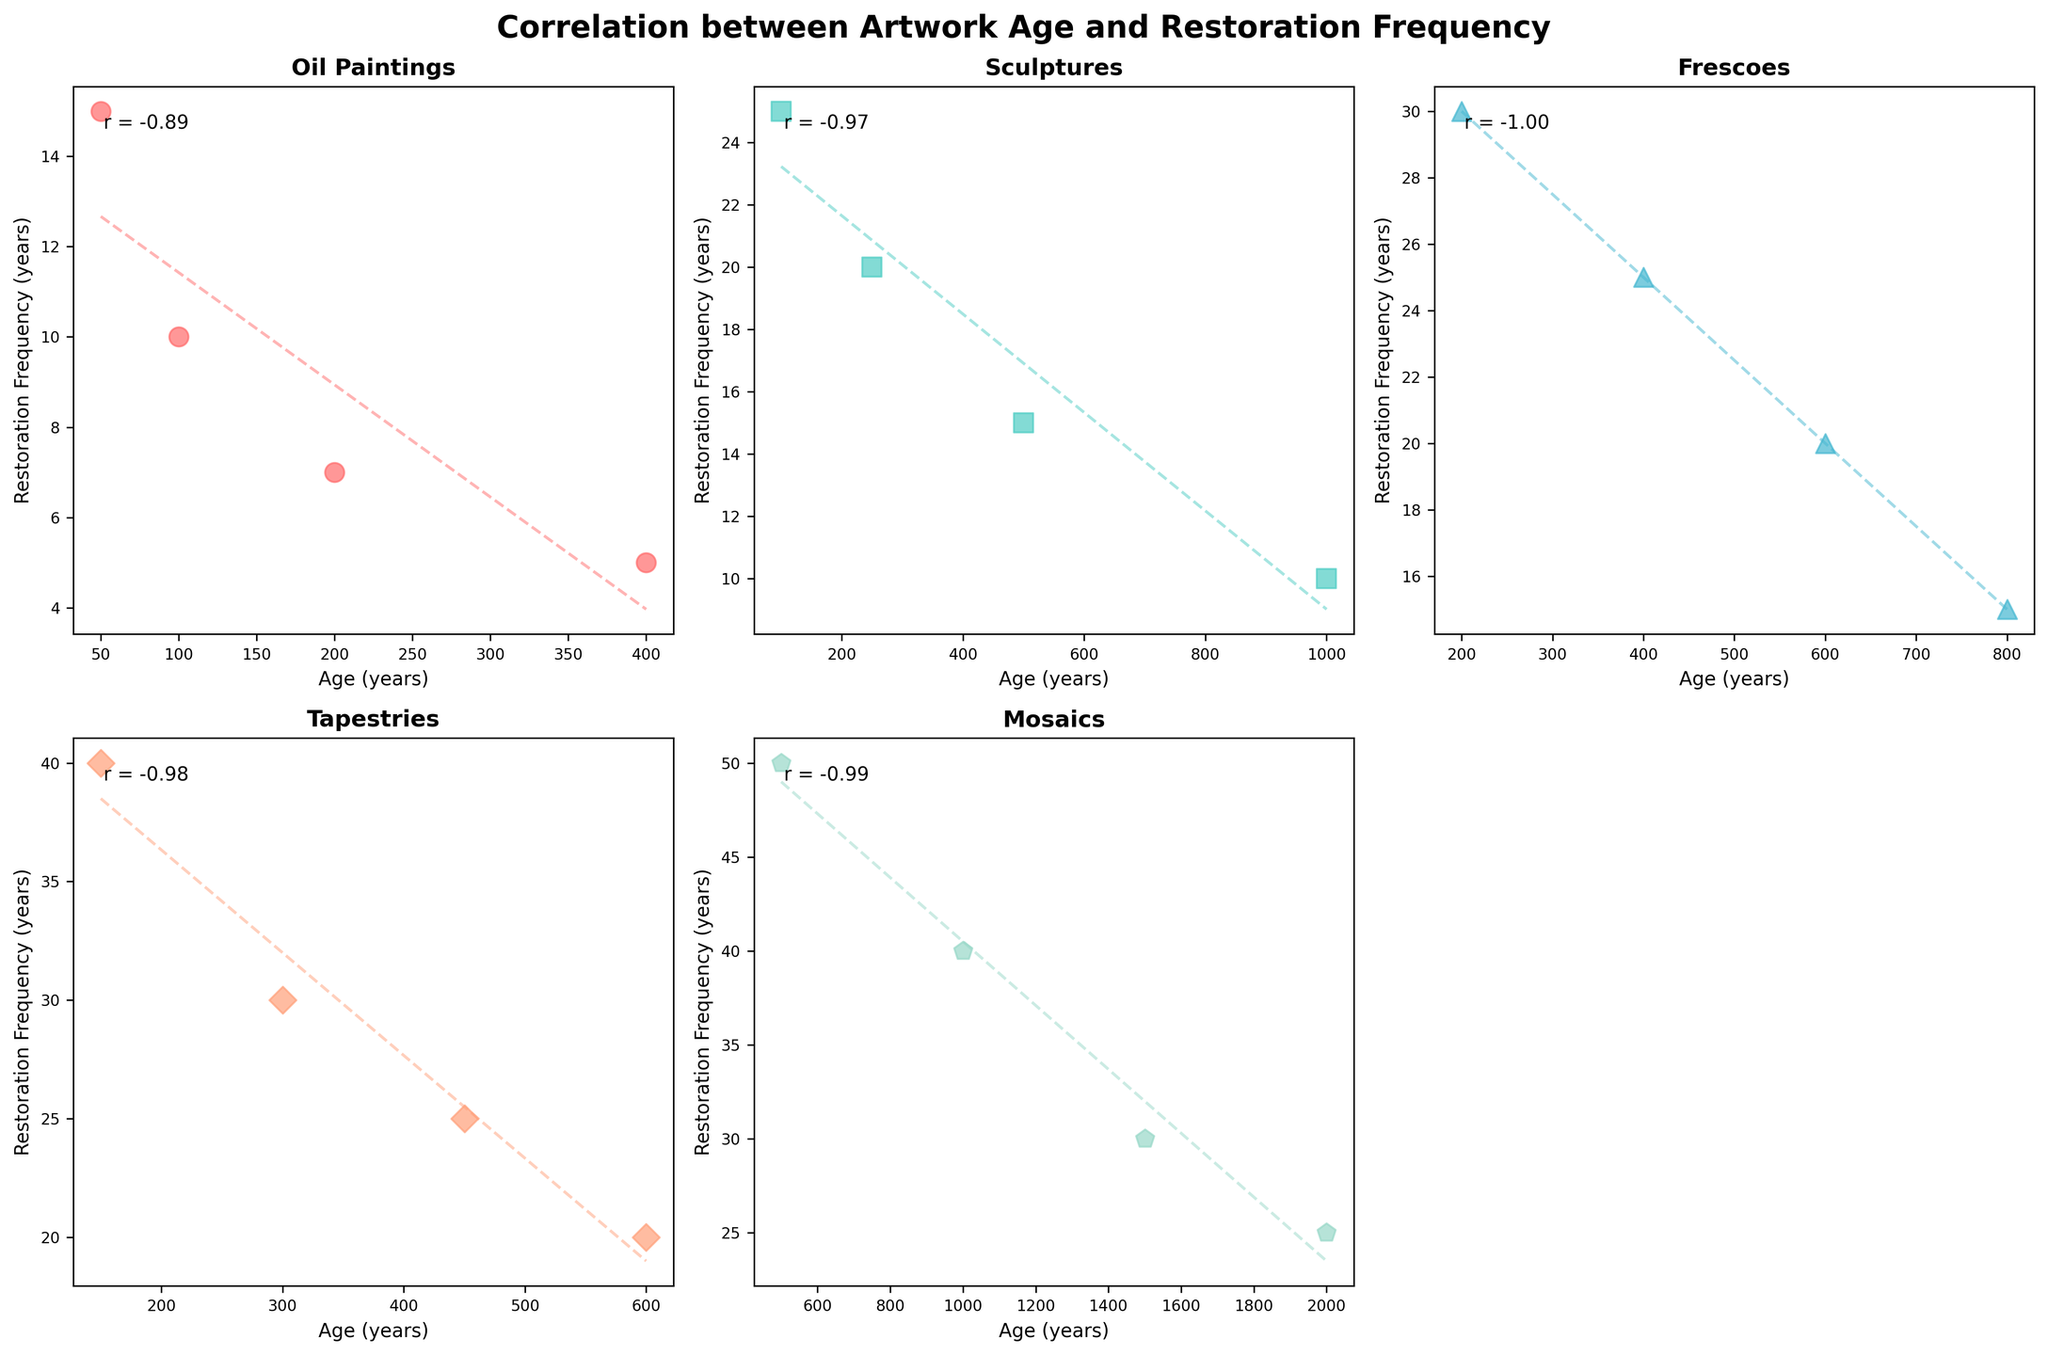What is the art form with the highest correlation coefficient? By looking at each subplot, we can see the annotated correlation coefficients. The highest value (0.98) appears in the subplot for "Mosaics".
Answer: Mosaics Which art form has the lowest frequency of restoration for the oldest samples? Check the oldest age label on the x-axis for each subplot. "Mosaics" aged 2000 years have the lowest restoration frequency with a value of 25 years.
Answer: Mosaics How does the restoration frequency change as the age of oil paintings increases? Observe the trendline in the "Oil Paintings" subplot. The data points as well as the line indicate that restoration frequency decreases as the age increases.
Answer: Decreases Which art form seems to require restoration more frequently as its age increases? Review the trendlines for each subplot. Both "Sculptures" and "Frescoes" show a clear trend that restoration frequency decreases as the age increases, which implies a more frequent restoration as time goes on.
Answer: Sculptures and Frescoes Compare the correlation coefficients between "Oil Paintings" and "Tapestries". Which one is stronger? Look at the annotated correlation coefficients for each subplot. "Oil Paintings" has a coefficient of -0.94, while "Tapestries" has -0.98. "Tapestries" has a stronger (more negative) correlation.
Answer: Tapestries What is the approximate correlation coefficient of "Frescoes"? Check the annotation in the "Frescoes" subplot. The approximate correlation coefficient is -0.99.
Answer: -0.99 For sculptures aged 500 years, what is the restoration frequency? Locate the data point on the "Sculptures" subplot where the age is 500 years. The restoration frequency at that point is 15 years.
Answer: 15 years If we rank the art forms by the steepness of their trendline slopes, which would be the steepest negative slope? Evaluate the trendlines visually. "Frescoes" appear to have the steepest negative slope compared to other categories.
Answer: Frescoes Which art form has the widest range of restoration frequencies? Check the y-axis range along with the spread of data points in each subplot. "Mosaics" have the widest range with frequencies from 25 to 50 years.
Answer: Mosaics How many data points are there for each art form grid? Count the data points in each subplot. All subplots have four data points each, representing different age intervals.
Answer: 4 